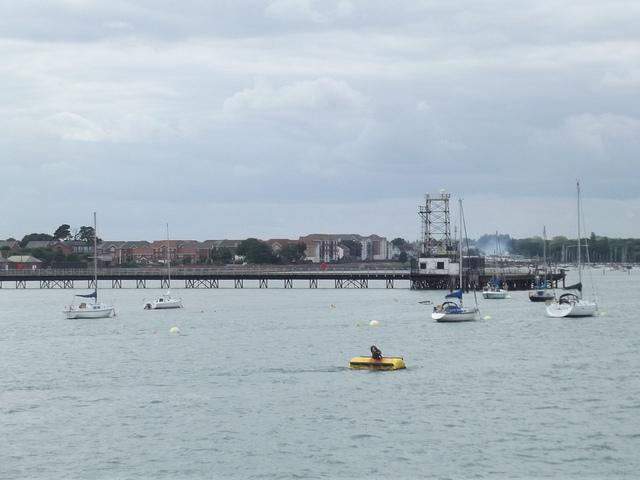What do many of the boats shown here normally use but lack here? sails 